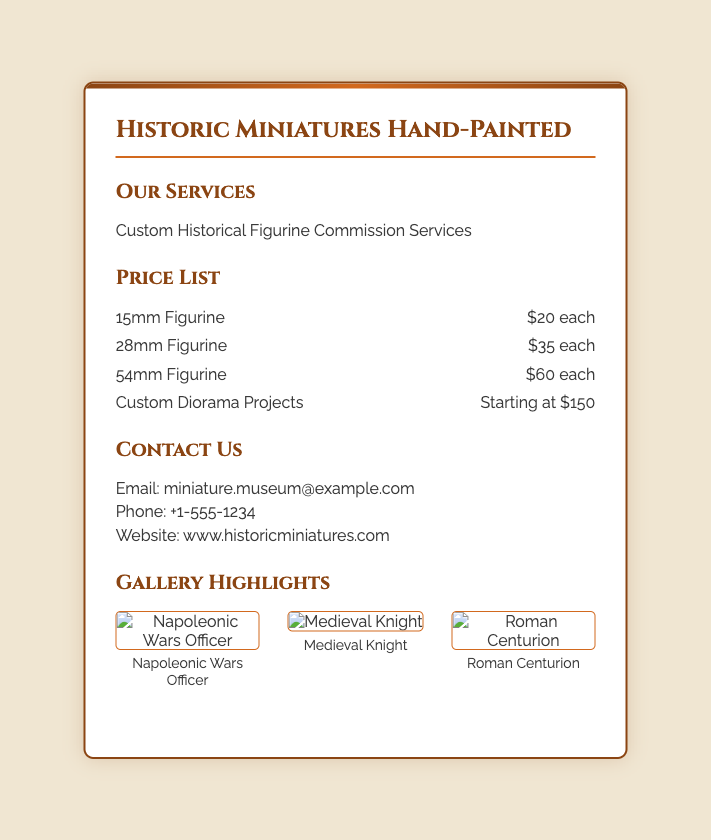what services are offered? The services offered are detailed in the "Our Services" section of the document.
Answer: Custom Historical Figurine Commission Services what is the price of a 28mm figurine? The price of a 28mm figurine is listed in the price list section.
Answer: $35 each how many gallery images are shown? The number of images can be counted in the gallery section of the document.
Answer: 3 what is the starting price for custom diorama projects? The starting price for custom diorama projects is found in the price list.
Answer: $150 what email address is provided for contact? The email address for contact is found in the "Contact Us" section of the document.
Answer: miniature.museum@example.com which historical figure is depicted in the first gallery image? The name of the historical figure is mentioned below the first image in the gallery.
Answer: Napoleonic Wars Officer how does the background color of the card appear? The background color can be seen in the overall design of the document.
Answer: #f0e6d2 what is the phone number for contacting the service? The phone number is provided in the contact section of the document.
Answer: +1-555-1234 